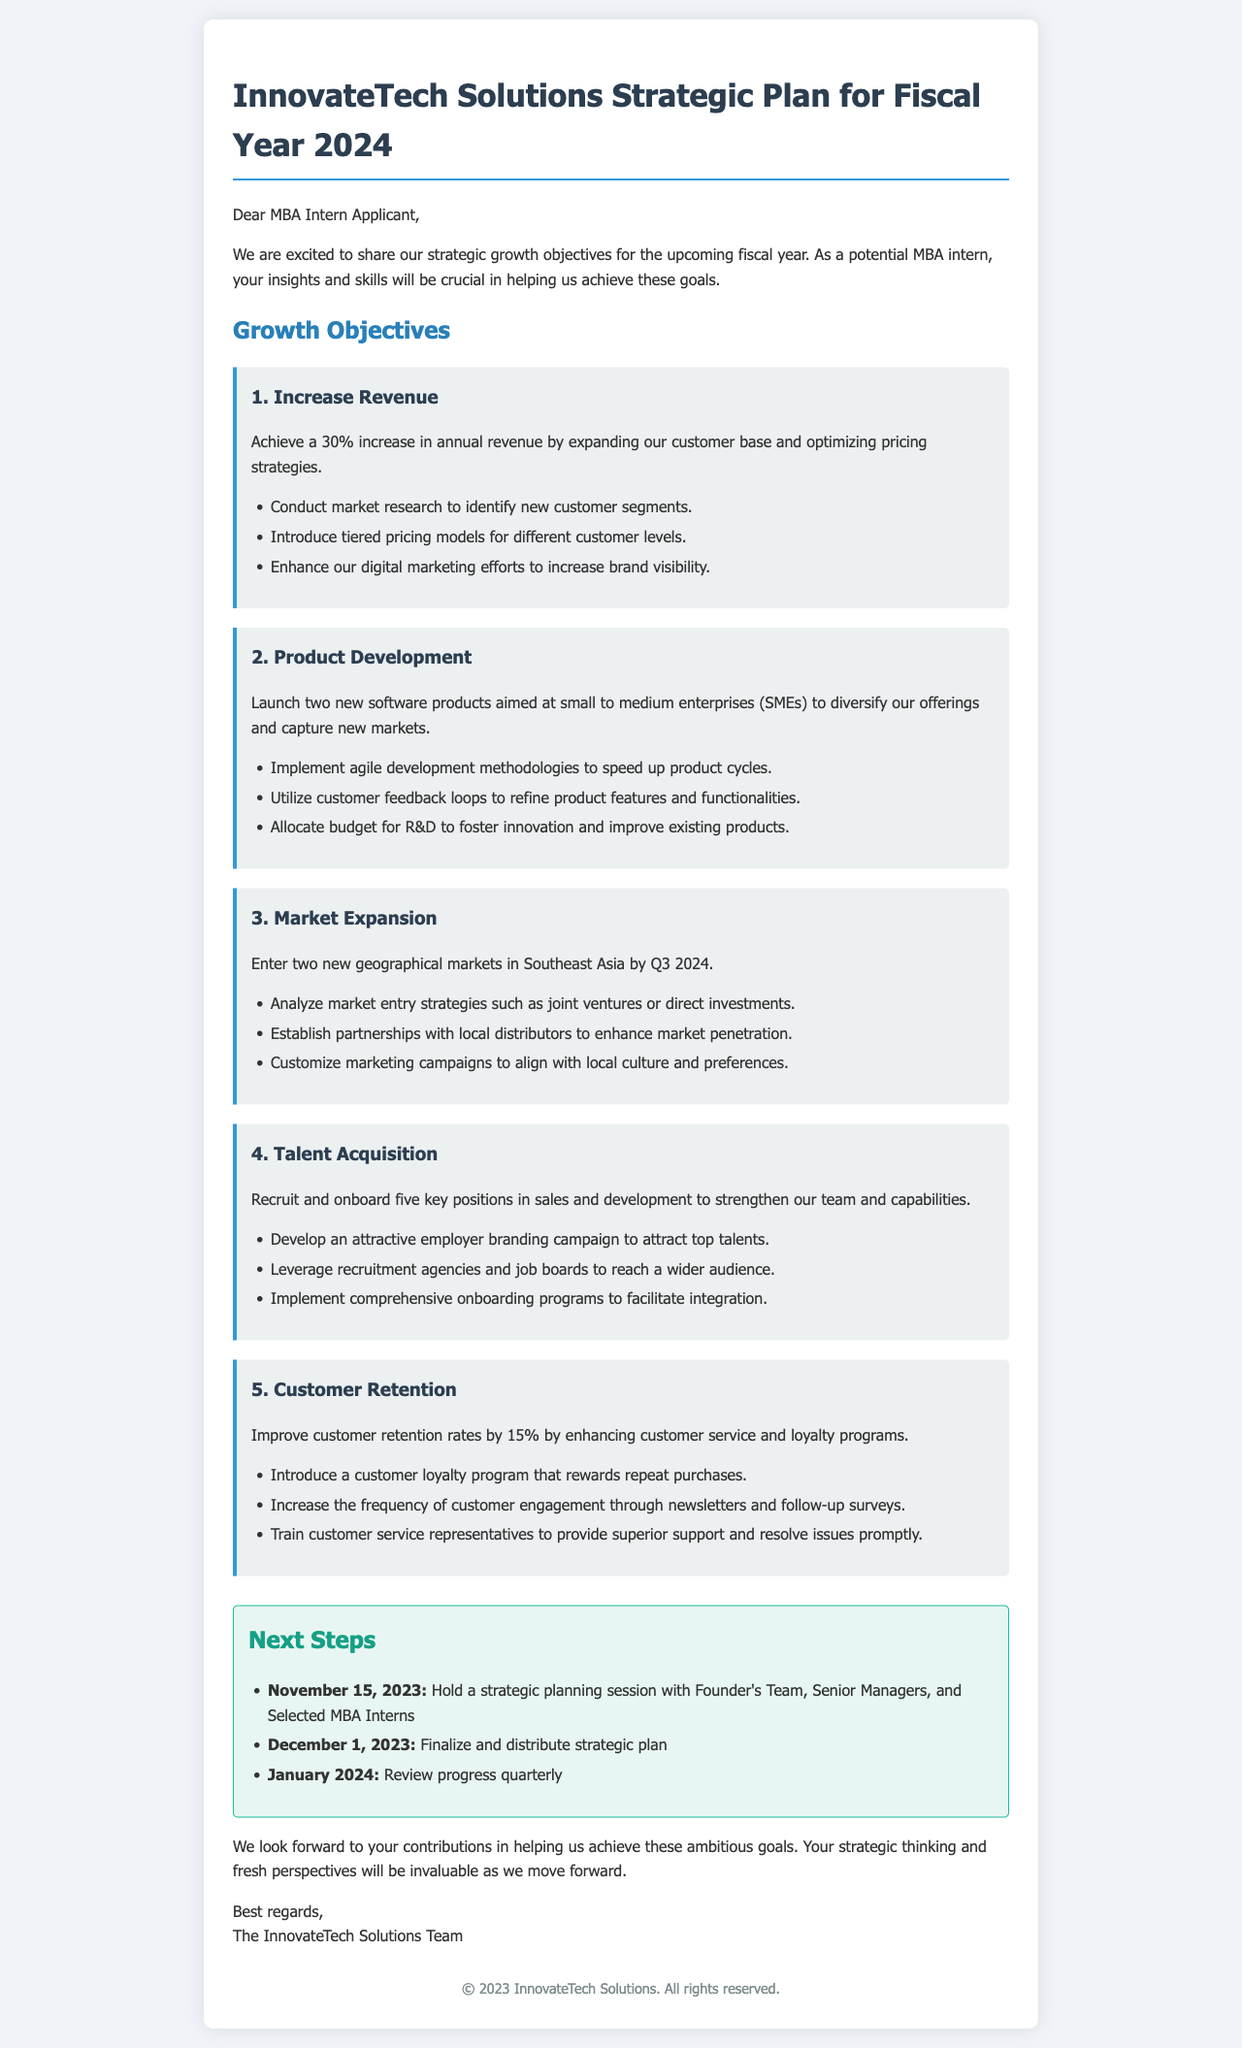What is the title of the document? The title of the document is stated in the header section, which introduces the strategic plan for the fiscal year.
Answer: InnovateTech Solutions Strategic Plan for Fiscal Year 2024 What is the revenue increase target? The revenue increase target is mentioned explicitly in the first growth objective under the section "Growth Objectives."
Answer: 30% How many new software products are planned for launch? The number of new software products to be launched is explicitly mentioned in the second objective.
Answer: Two What is the deadline for entering new geographical markets? The deadline for entering new geographical markets is provided in the third growth objective.
Answer: Q3 2024 How many key positions are planned to be recruited? The planned number of key positions to be recruited is stated in the fourth growth objective.
Answer: Five What is the customer retention rate improvement target? The improvement target for customer retention rates is specified in the fifth growth objective.
Answer: 15% When will the strategic planning session be held? The date for the strategic planning session is provided in the "Next Steps" section.
Answer: November 15, 2023 What type of marketing strategy will be enhanced? The type of strategy mentioned for enhancement is outlined in the first growth objective.
Answer: Digital marketing efforts What campaign is suggested for attracting top talents? The type of campaign suggested to attract top talents is described in the fourth growth objective.
Answer: Employer branding campaign 